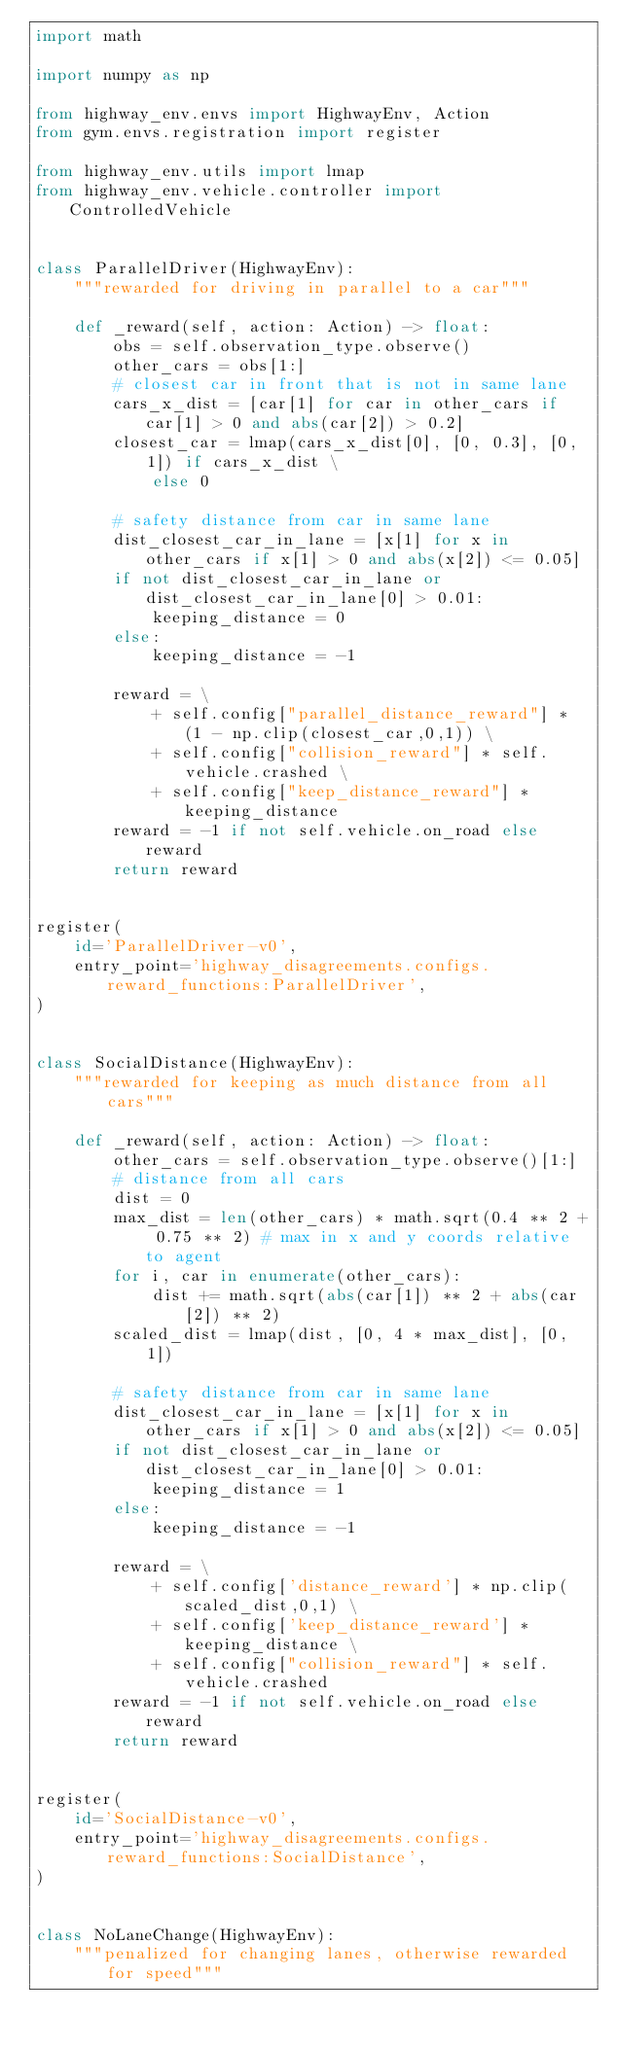Convert code to text. <code><loc_0><loc_0><loc_500><loc_500><_Python_>import math

import numpy as np

from highway_env.envs import HighwayEnv, Action
from gym.envs.registration import register

from highway_env.utils import lmap
from highway_env.vehicle.controller import ControlledVehicle


class ParallelDriver(HighwayEnv):
    """rewarded for driving in parallel to a car"""

    def _reward(self, action: Action) -> float:
        obs = self.observation_type.observe()
        other_cars = obs[1:]
        # closest car in front that is not in same lane
        cars_x_dist = [car[1] for car in other_cars if car[1] > 0 and abs(car[2]) > 0.2]
        closest_car = lmap(cars_x_dist[0], [0, 0.3], [0, 1]) if cars_x_dist \
            else 0

        # safety distance from car in same lane
        dist_closest_car_in_lane = [x[1] for x in other_cars if x[1] > 0 and abs(x[2]) <= 0.05]
        if not dist_closest_car_in_lane or dist_closest_car_in_lane[0] > 0.01:
            keeping_distance = 0
        else:
            keeping_distance = -1

        reward = \
            + self.config["parallel_distance_reward"] * (1 - np.clip(closest_car,0,1)) \
            + self.config["collision_reward"] * self.vehicle.crashed \
            + self.config["keep_distance_reward"] * keeping_distance
        reward = -1 if not self.vehicle.on_road else reward
        return reward


register(
    id='ParallelDriver-v0',
    entry_point='highway_disagreements.configs.reward_functions:ParallelDriver',
)


class SocialDistance(HighwayEnv):
    """rewarded for keeping as much distance from all cars"""

    def _reward(self, action: Action) -> float:
        other_cars = self.observation_type.observe()[1:]
        # distance from all cars
        dist = 0
        max_dist = len(other_cars) * math.sqrt(0.4 ** 2 + 0.75 ** 2) # max in x and y coords relative to agent
        for i, car in enumerate(other_cars):
            dist += math.sqrt(abs(car[1]) ** 2 + abs(car[2]) ** 2)
        scaled_dist = lmap(dist, [0, 4 * max_dist], [0, 1])

        # safety distance from car in same lane
        dist_closest_car_in_lane = [x[1] for x in other_cars if x[1] > 0 and abs(x[2]) <= 0.05]
        if not dist_closest_car_in_lane or dist_closest_car_in_lane[0] > 0.01:
            keeping_distance = 1
        else:
            keeping_distance = -1

        reward = \
            + self.config['distance_reward'] * np.clip(scaled_dist,0,1) \
            + self.config['keep_distance_reward'] * keeping_distance \
            + self.config["collision_reward"] * self.vehicle.crashed
        reward = -1 if not self.vehicle.on_road else reward
        return reward


register(
    id='SocialDistance-v0',
    entry_point='highway_disagreements.configs.reward_functions:SocialDistance',
)


class NoLaneChange(HighwayEnv):
    """penalized for changing lanes, otherwise rewarded for speed"""
</code> 